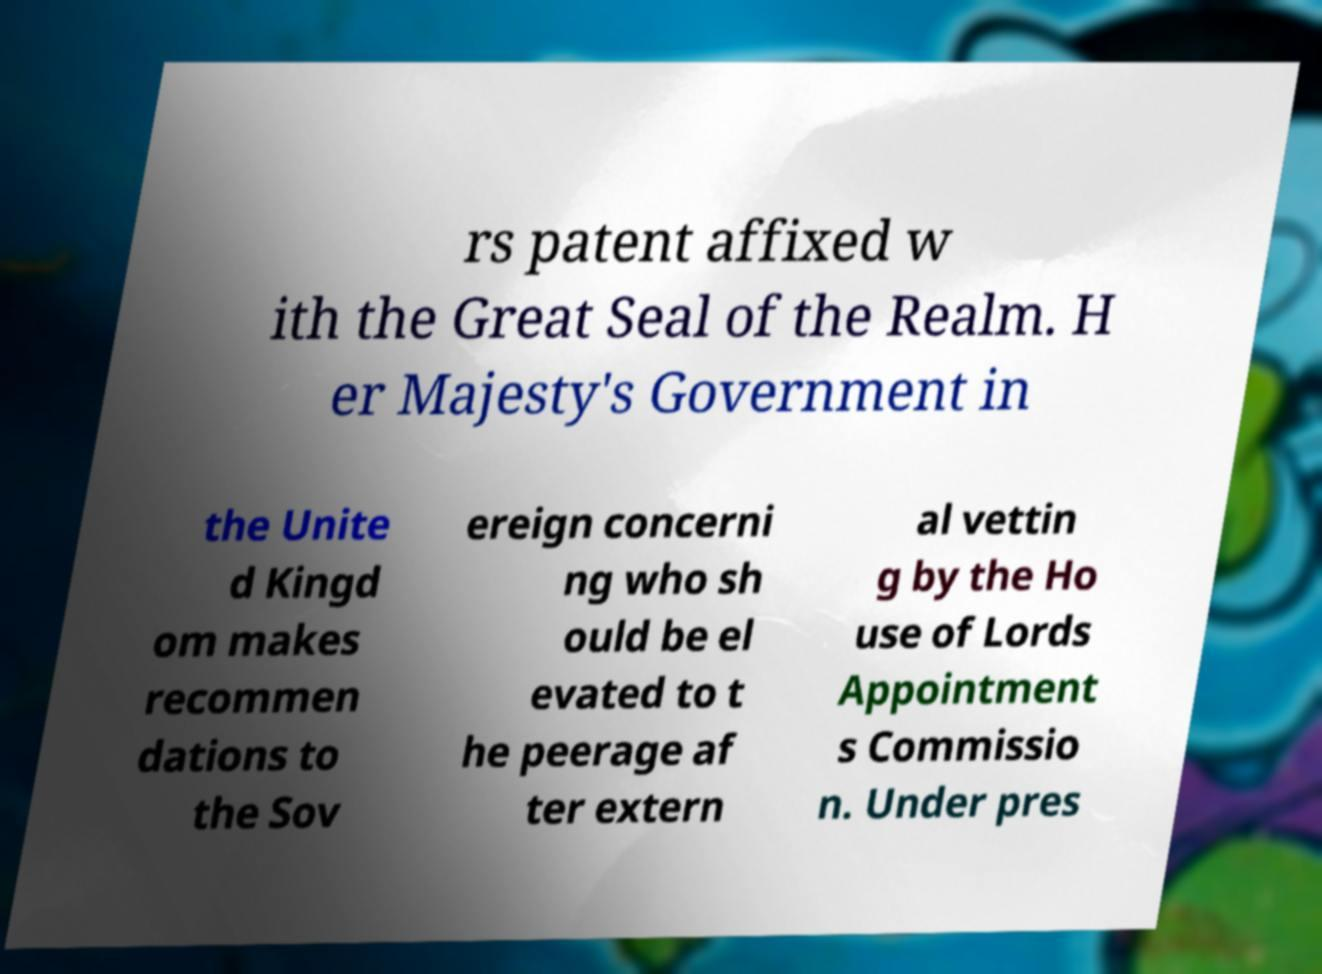Can you accurately transcribe the text from the provided image for me? rs patent affixed w ith the Great Seal of the Realm. H er Majesty's Government in the Unite d Kingd om makes recommen dations to the Sov ereign concerni ng who sh ould be el evated to t he peerage af ter extern al vettin g by the Ho use of Lords Appointment s Commissio n. Under pres 